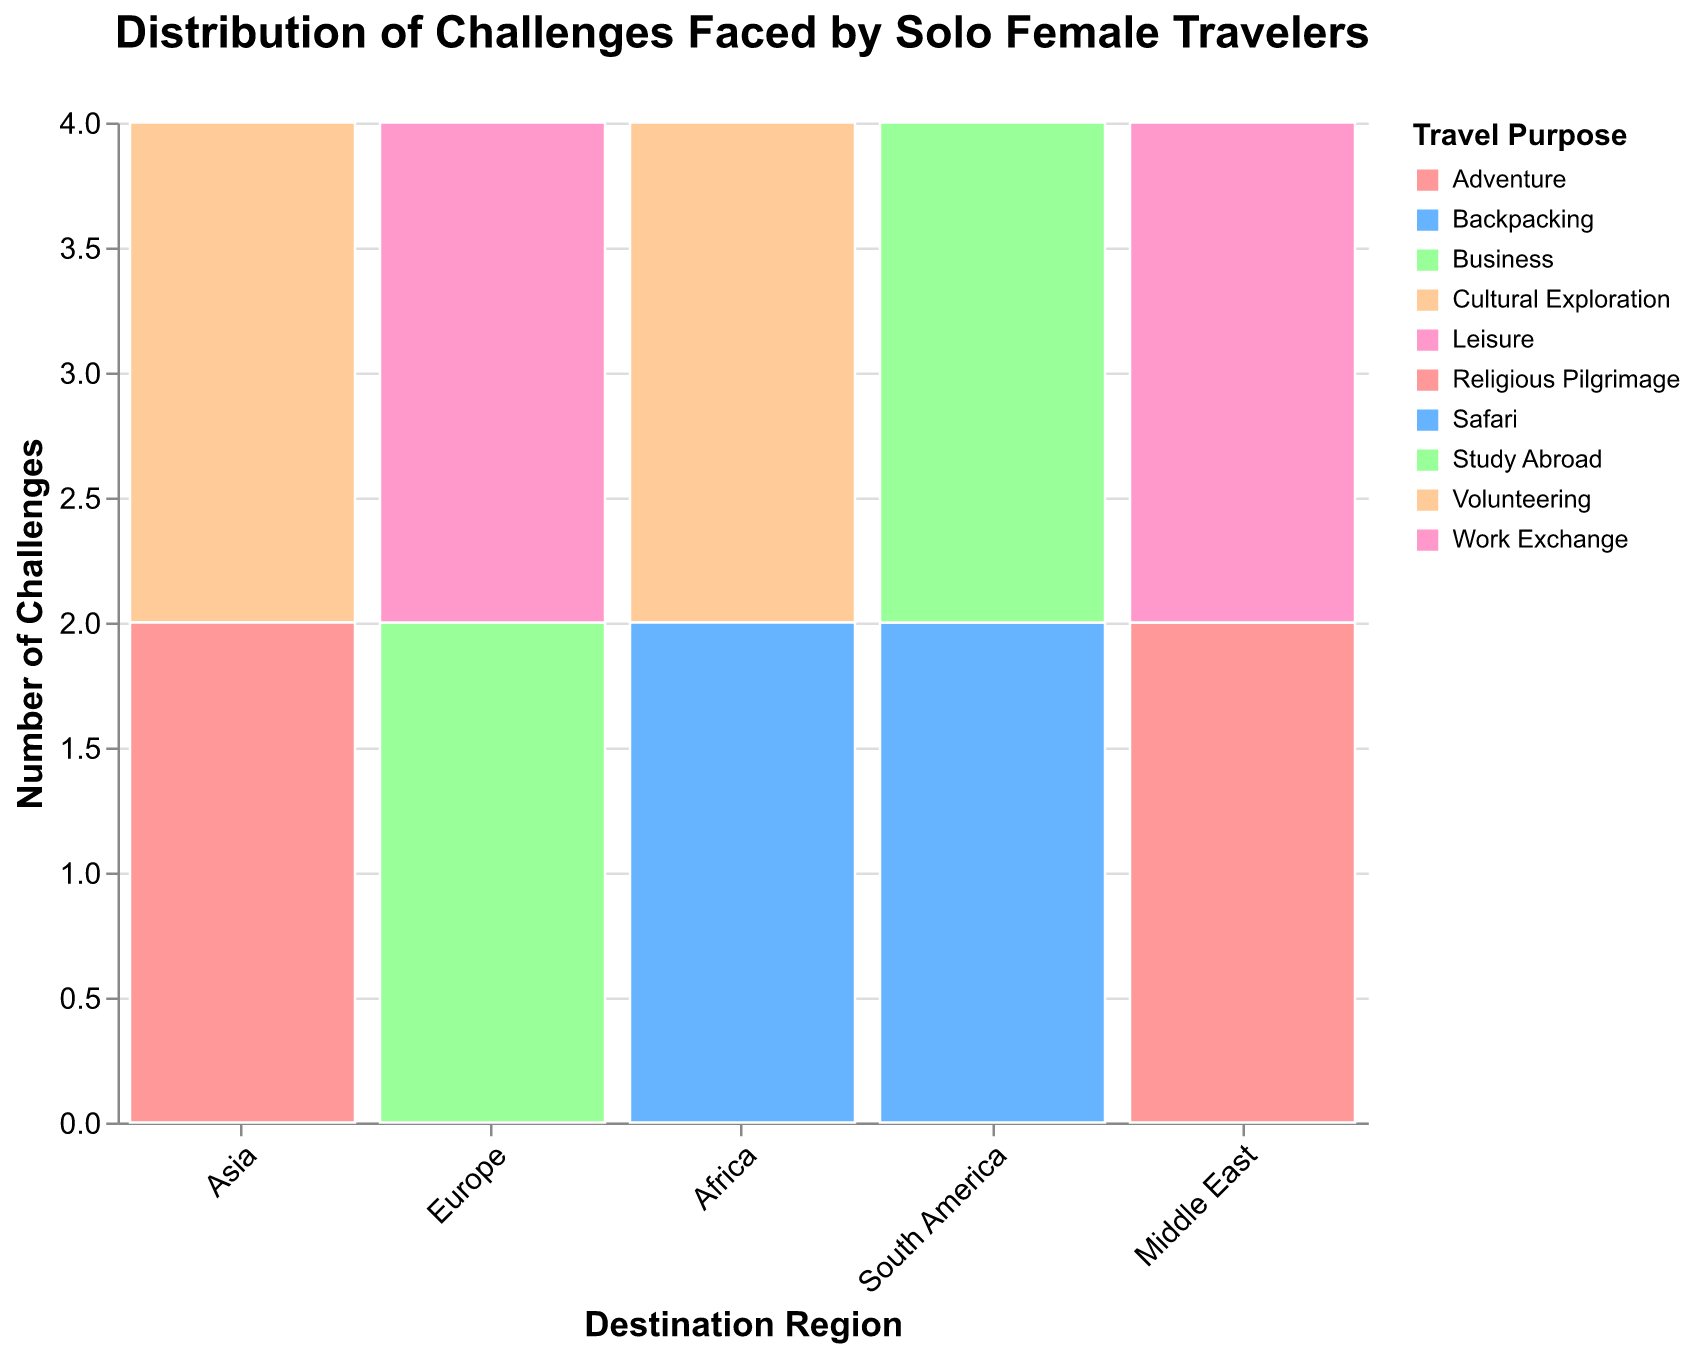What is the title of the figure? The title is usually displayed at the top of the figure. From the specified code, we see that the title is: "Distribution of Challenges Faced by Solo Female Travelers".
Answer: Distribution of Challenges Faced by Solo Female Travelers Which region has the highest number of challenges identified? Look at the y-axis values for each region and see which has the highest bar in total. Based on the listed data, all regions should be compared to identify the highest count.
Answer: Asia What color represents the 'Adventure' travel purpose? The color encoding section defines a range of colors for different travel purposes; checking it, we see that Adventure is represented by a specific shade.
Answer: Light Blue How many challenges are listed for volunteering in Africa? Check the height of the bars within the 'Africa' region colored under volunteering and count the number of challenges.
Answer: Two Which two regions are closest in terms of the number of challenges? Compare the heights of the bars for each region and determine which pairs have the closest total height.
Answer: South America and Middle East How does the total number of challenges faced in Europe compare to those faced in Africa? Sum the heights of the bars for both Europe and Africa and compare them directly.
Answer: Europe has more challenges Which travel purpose has the most variety in terms of regions? Identify the travel purpose that appears across the most different regions by looking at the color distribution across regions.
Answer: Cultural Exploration Is there any region where 'Business' travel is the only represented purpose? Check each region and see if 'Business' is the only travel purpose represented in that region by looking at the colors.
Answer: No For the Middle East region, which travel purpose has the least challenges identified? Compare the heights of bars within the Middle East region for different travel purposes and identify the smallest.
Answer: Work Exchange Does 'Study Abroad' face more challenges in South America or volunteering in Africa? Compare the total height of bars for 'Study Abroad' in South America with the height of bars for volunteering in Africa.
Answer: Study Abroad in South America 